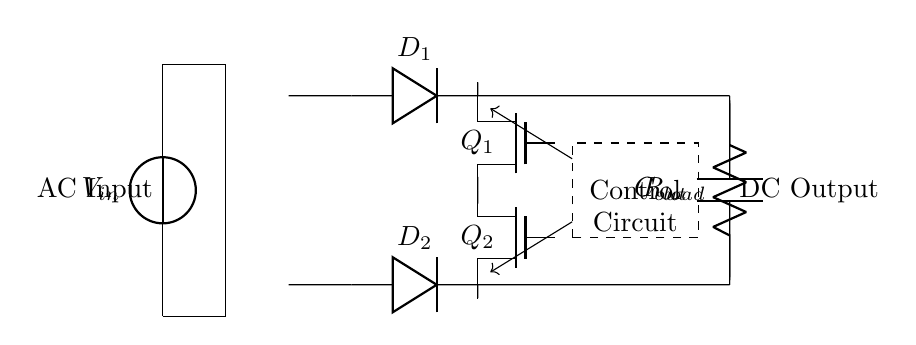What are the main components of the circuit? The circuit includes a transformer, two diodes (D1, D2), two N-channel MOSFETs (Q1, Q2), a control circuit, an output capacitor (Cout), and a load resistor (Rload). These components work together to rectify AC input into DC output efficiently.
Answer: transformer, D1, D2, Q1, Q2, control circuit, Cout, Rload What is the role of the diodes in this circuit? The diodes (D1 and D2) in the synchronous rectifier circuit are used to allow current to flow in one direction, thus converting the alternating current (AC) to direct current (DC). They are essential for ensuring that the current only passes during the correct phase of the signal, which aids in efficient rectification.
Answer: convert AC to DC How does the control circuit interact with the MOSFETs? The control circuit generates signals that control the gate operations of the N-channel MOSFETs (Q1 and Q2). These control signals turn the MOSFETs on and off at the appropriate times to replace the function of the diodes, allowing for lower voltage drops and improved efficiency.
Answer: controls gate operations What is the significance of using N-channel MOSFETs instead of diodes? N-channel MOSFETs have a lower on-resistance compared to diodes when conducting, which results in lower power losses and higher efficiency in the rectification process. This advantage is crucial for applications in switch-mode power supplies where minimizing energy loss is essential.
Answer: lower power losses How does the output capacitor impact the rectified voltage? The output capacitor (Cout) smooths the pulsating DC voltage from the rectifier by storing charge and releasing it to maintain a steady voltage level at the output. This smoothing effect helps to minimize voltage ripple, which results in a more stable and usable DC output for the load.
Answer: smooths pulsating DC voltage What type of rectification does this circuit perform? This circuit performs synchronous rectification, which utilizes MOSFETs instead of traditional diodes to reduce conduction losses and improve overall efficiency in converting AC to DC. The synchronous operation dynamically switches the MOSFETs to achieve this goal.
Answer: synchronous rectification 